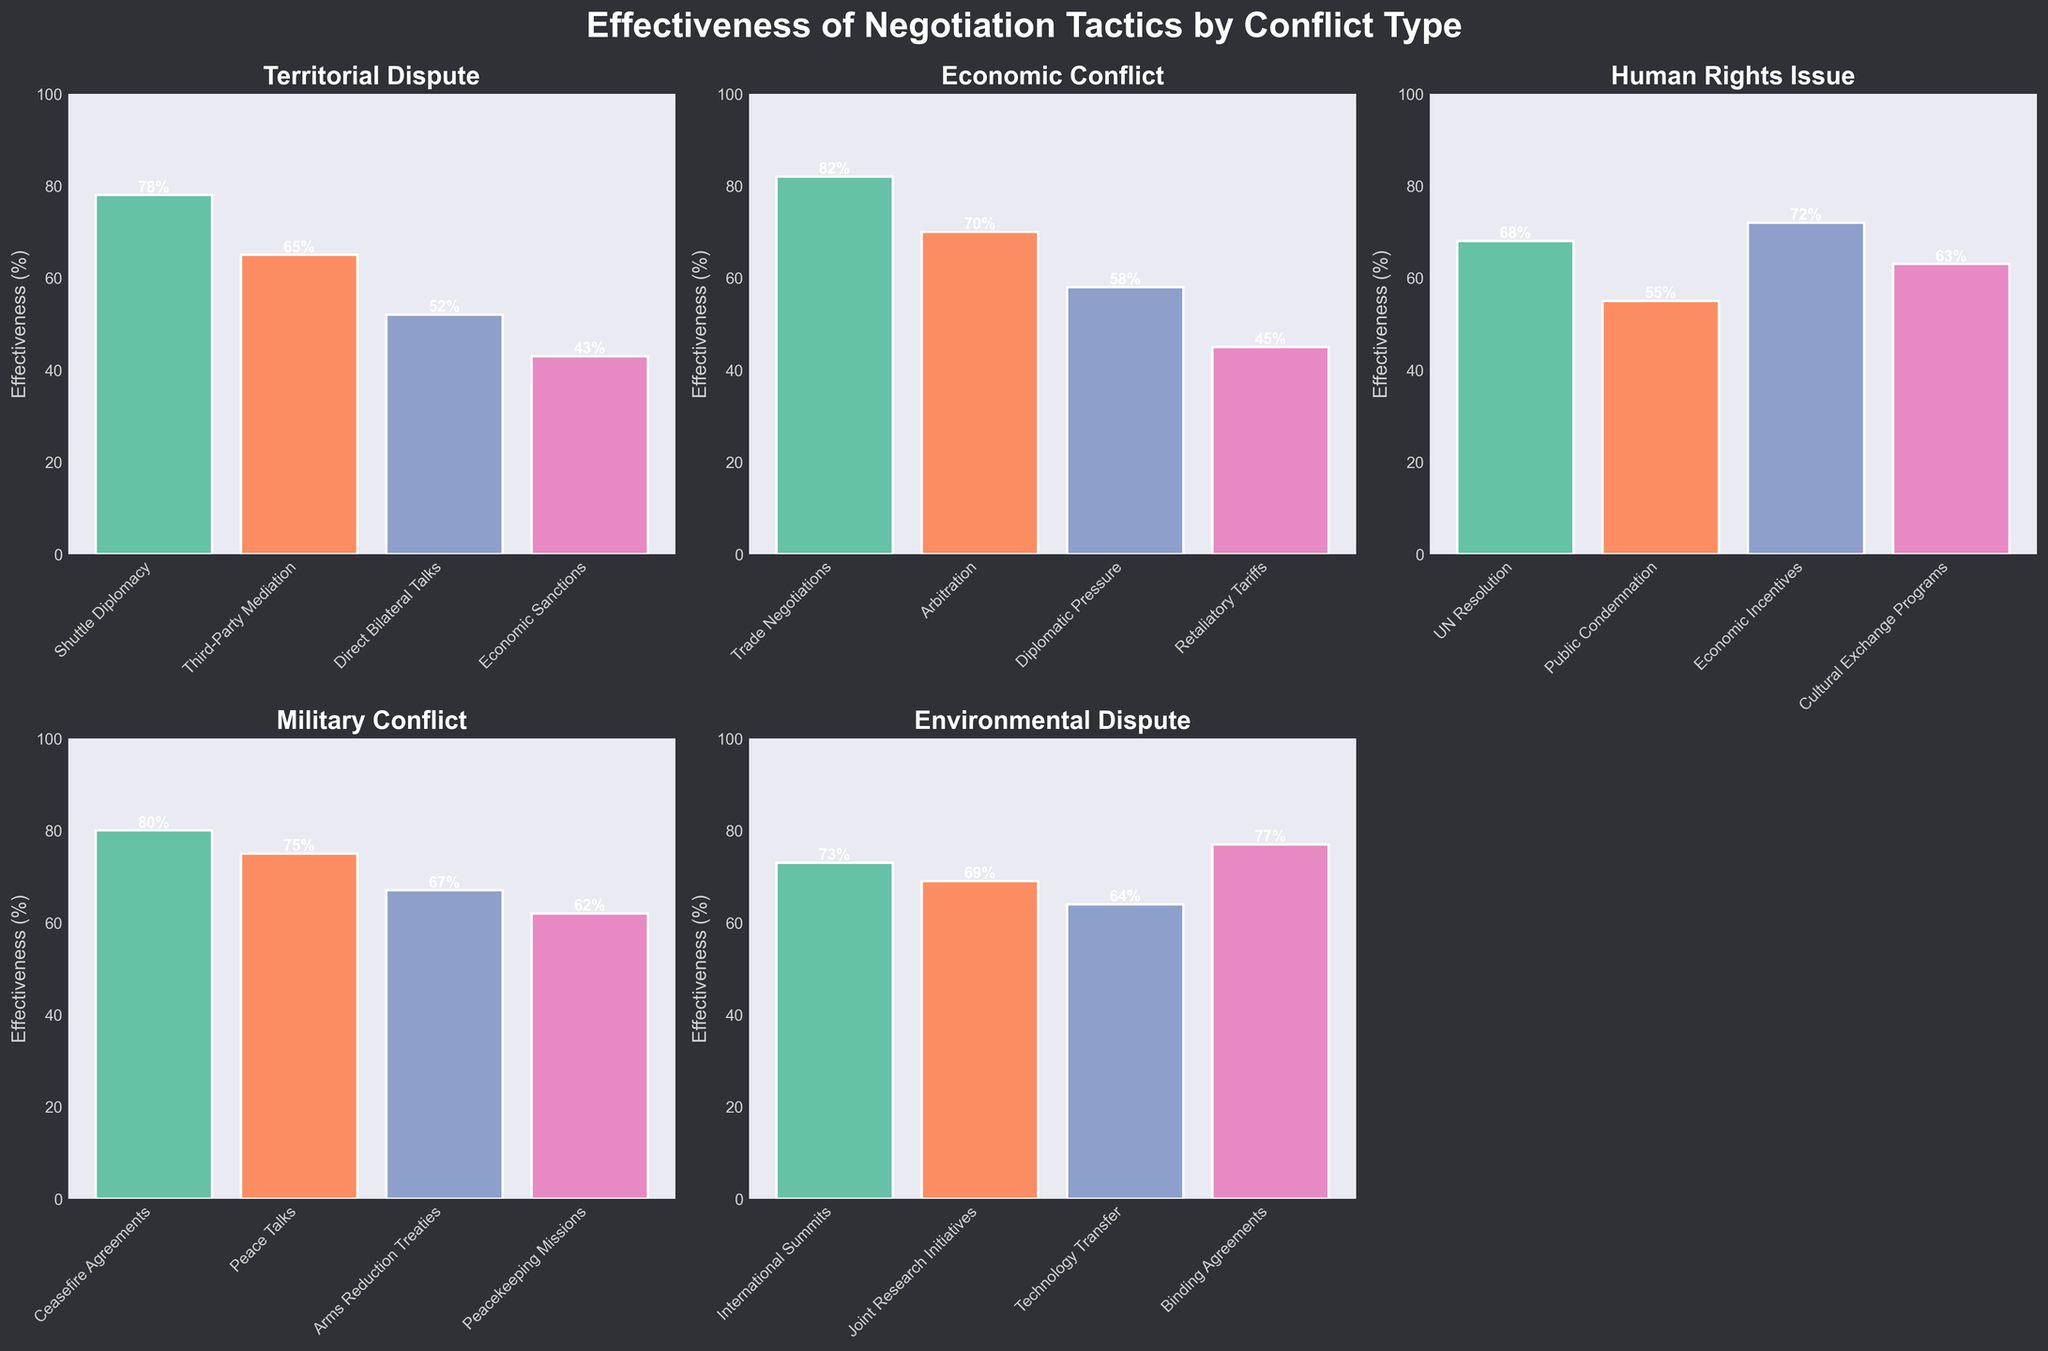What is the title of the chart? The title is located at the top center of the chart in bold and white text. It reads "Effectiveness of Negotiation Tactics by Conflict Type."
Answer: Effectiveness of Negotiation Tactics by Conflict Type What is the effectiveness percentage of Binding Agreements in Environmental Dispute? Locate the subplot for "Environmental Dispute" and find the bar labeled "Binding Agreements." The effectiveness percentage is written above the bar.
Answer: 77% Which negotiation tactic is the most effective in resolving Economic Conflict? Look at the subplot for "Economic Conflict" and identify the tallest bar. Read the tactic label under this bar.
Answer: Trade Negotiations Order the negotiation tactics for Human Rights Issue based on their effectiveness from highest to lowest. Find the "Human Rights Issue" subplot. List the tactics from the tallest bar to the shortest bar by reading the labels and their respective percentages.
Answer: Economic Incentives (72%), UN Resolution (68%), Cultural Exchange Programs (63%), Public Condemnation (55%) What is the average effectiveness of the tactics used in resolving Military Conflict? For the "Military Conflict" subplot, sum the effectiveness percentages for all tactics and then divide by the total number of tactics (4). The calculation is (80 + 75 + 67 + 62) / 4.
Answer: 71% Between Third-Party Mediation in Territorial Dispute and Arbitration in Economic Conflict, which is more effective? Compare the bar heights and percentages for "Third-Party Mediation" in the "Territorial Dispute" subplot and "Arbitration" in the "Economic Conflict" subplot.
Answer: Arbitration in Economic Conflict What is the total number of negotiation tactics presented across all conflict types? Count all the bars in every subplot. There are 5 subplots with 4 tactics each plus an additional three tactics in one subplot. Summing these gives 23 tactics.
Answer: 23 Is the effectiveness of Cultural Exchange Programs higher than that of Economic Sanctions? By how much? Compare the effectiveness percentages of "Cultural Exchange Programs" in the "Human Rights Issue" subplot to "Economic Sanctions" in the "Territorial Dispute" subplot. Subtract the smaller value from the larger one. The calculation is 63% - 43%.
Answer: Yes, by 20% In which conflict type does Technology Transfer appear, and what is its effectiveness? Look through each subplot to identify where "Technology Transfer" is listed. Read the effectiveness percentage associated with this tactic.
Answer: Environmental Dispute, 64% What's the least effective negotiation tactic in the Territorial Dispute conflict type? In the subplot for "Territorial Dispute," identify the shortest bar and read the label.
Answer: Economic Sanctions 